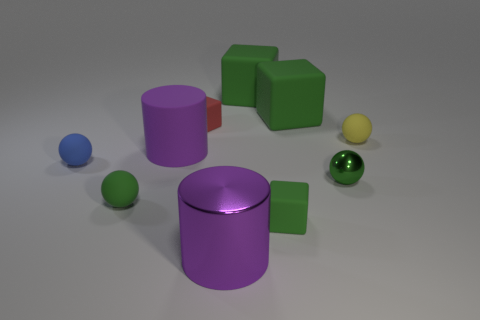How many green blocks must be subtracted to get 1 green blocks? 2 Subtract all cyan cubes. How many green balls are left? 2 Subtract 2 blocks. How many blocks are left? 2 Subtract all small green blocks. How many blocks are left? 3 Subtract all red cubes. How many cubes are left? 3 Subtract all cyan spheres. Subtract all gray cylinders. How many spheres are left? 4 Subtract all spheres. How many objects are left? 6 Add 4 gray shiny things. How many gray shiny things exist? 4 Subtract 0 purple blocks. How many objects are left? 10 Subtract all large blue metallic cubes. Subtract all large green cubes. How many objects are left? 8 